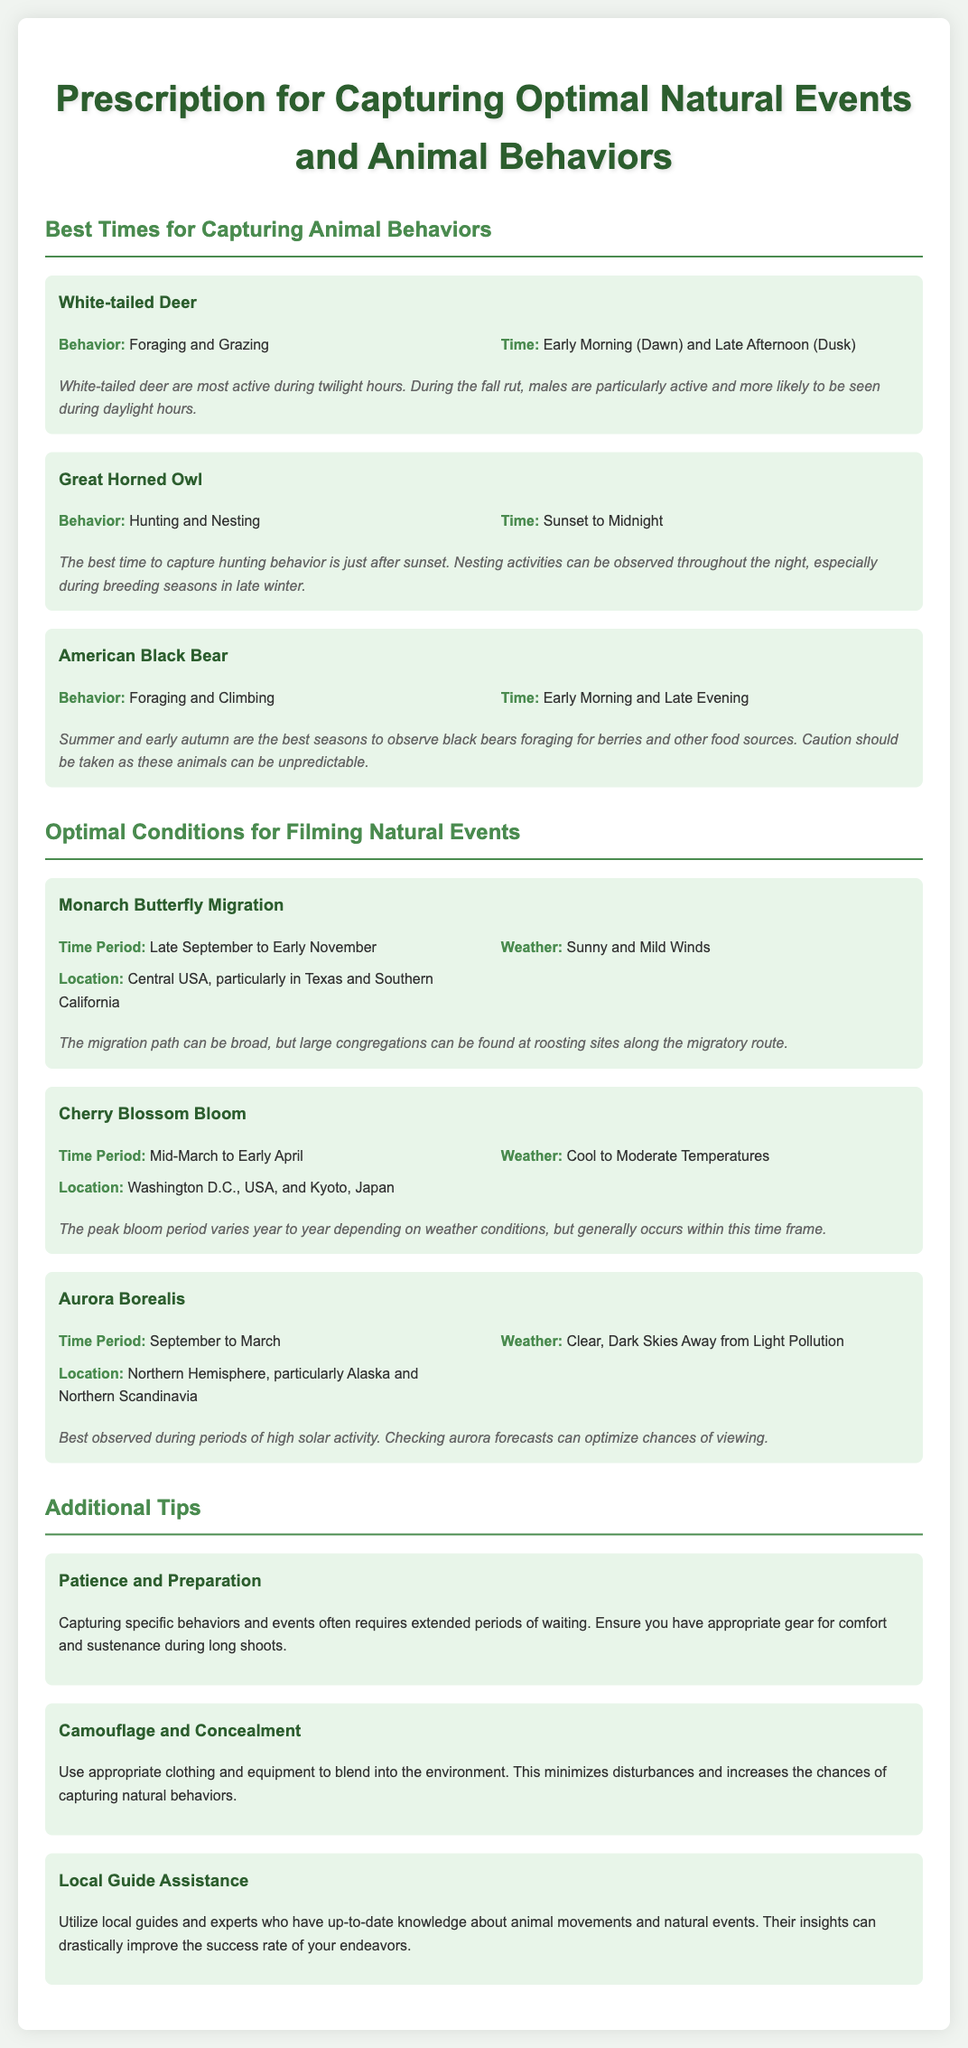What is the best time to capture the White-tailed Deer? The document states that the best times to capture White-tailed Deer are Early Morning (Dawn) and Late Afternoon (Dusk).
Answer: Early Morning (Dawn) and Late Afternoon (Dusk) What behavior can be observed in Great Horned Owls? The document indicates that Great Horned Owls exhibit Hunting and Nesting behaviors.
Answer: Hunting and Nesting When do Monarch Butterflies migrate? According to the document, Monarch Butterflies migrate from Late September to Early November.
Answer: Late September to Early November What weather conditions are optimal for filming the Aurora Borealis? The document specifies that clear, dark skies away from light pollution are the optimal weather conditions for filming Aurora Borealis.
Answer: Clear, Dark Skies Away from Light Pollution What is an important tip for capturing specific animal behaviors? The document recommends patience and preparation as an important tip for capturing specific animal behaviors.
Answer: Patience and Preparation Which location is best for observing Cherry Blossom Bloom? The document states that Washington D.C., USA, and Kyoto, Japan are the best locations for observing Cherry Blossom Bloom.
Answer: Washington D.C., USA, and Kyoto, Japan During which season are American Black Bears most active foraging? The document notes that summer and early autumn are when American Black Bears are most active foraging.
Answer: Summer and early autumn What animal is featured for its behavior of Foraging and Grazing? The document highlights the White-tailed Deer for its behavior of Foraging and Grazing.
Answer: White-tailed Deer How can local guides assist in capturing natural events? The document explains that local guides can provide up-to-date knowledge about animal movements and natural events.
Answer: Up-to-date knowledge about animal movements and natural events 